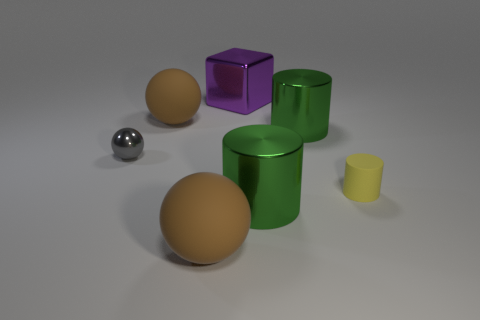How many brown balls must be subtracted to get 1 brown balls? 1 Add 3 tiny red cylinders. How many objects exist? 10 Subtract all cylinders. How many objects are left? 4 Subtract 0 gray cylinders. How many objects are left? 7 Subtract all gray metallic objects. Subtract all gray metal balls. How many objects are left? 5 Add 4 yellow rubber things. How many yellow rubber things are left? 5 Add 4 green metal objects. How many green metal objects exist? 6 